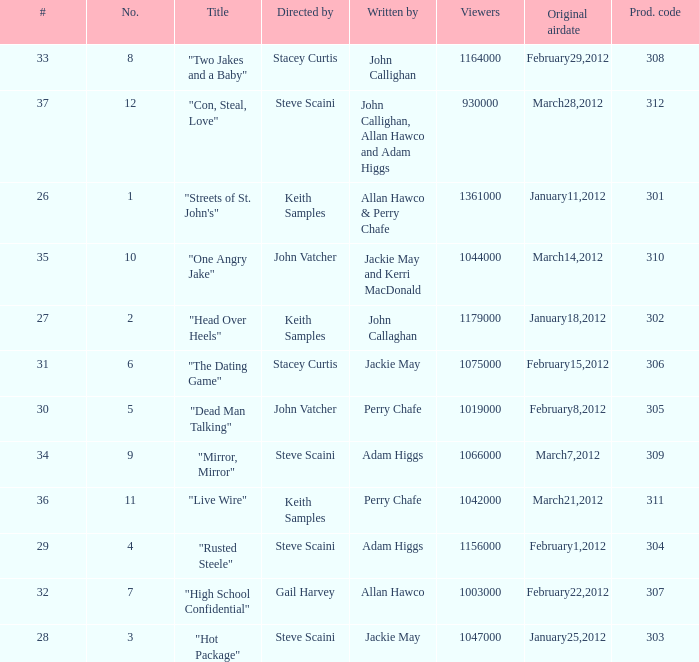What is the count of original airdate penned by allan hawco? 1.0. 